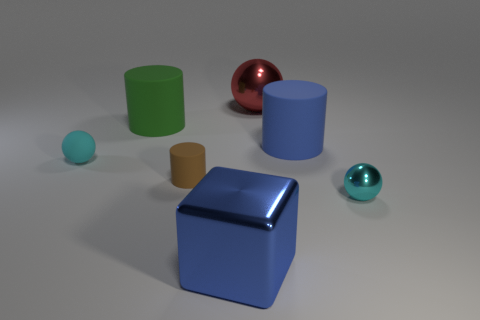There is a cyan object behind the brown thing to the left of the large shiny block; what is its size?
Keep it short and to the point. Small. There is another tiny thing that is the same shape as the blue rubber object; what is its material?
Offer a terse response. Rubber. What number of tiny blue cubes are there?
Make the answer very short. 0. What color is the small matte thing left of the rubber cylinder that is behind the rubber cylinder that is on the right side of the large blue shiny cube?
Give a very brief answer. Cyan. Is the number of large rubber cylinders less than the number of red objects?
Ensure brevity in your answer.  No. What is the color of the other large matte thing that is the same shape as the big green object?
Your answer should be compact. Blue. There is a large object that is the same material as the blue cylinder; what color is it?
Keep it short and to the point. Green. How many blue blocks have the same size as the blue matte cylinder?
Ensure brevity in your answer.  1. What is the material of the big sphere?
Your response must be concise. Metal. Is the number of purple blocks greater than the number of tiny brown things?
Your response must be concise. No. 